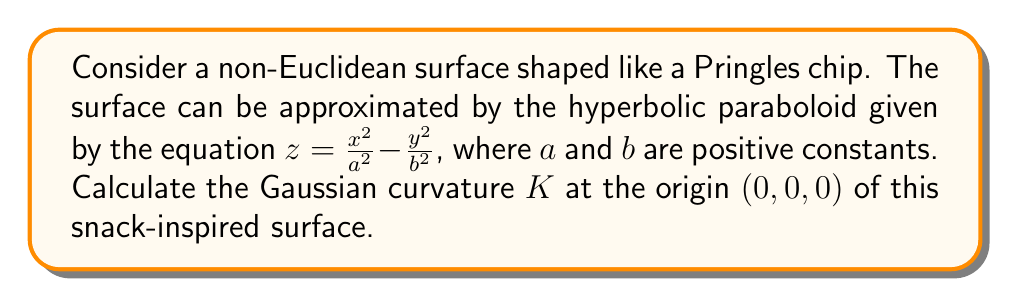Give your solution to this math problem. Let's approach this step-by-step:

1) The Gaussian curvature $K$ of a surface $z = f(x,y)$ at a point $(x,y)$ is given by:

   $$K = \frac{f_{xx}f_{yy} - f_{xy}^2}{(1 + f_x^2 + f_y^2)^2}$$

   where $f_x$, $f_y$, $f_{xx}$, $f_{yy}$, and $f_{xy}$ are partial derivatives.

2) For our surface $z = \frac{x^2}{a^2} - \frac{y^2}{b^2}$, let's calculate these derivatives:

   $f_x = \frac{2x}{a^2}$
   $f_y = -\frac{2y}{b^2}$
   $f_{xx} = \frac{2}{a^2}$
   $f_{yy} = -\frac{2}{b^2}$
   $f_{xy} = 0$

3) At the origin $(0,0,0)$, $x=0$ and $y=0$, so:

   $f_x(0,0) = 0$
   $f_y(0,0) = 0$
   $f_{xx}(0,0) = \frac{2}{a^2}$
   $f_{yy}(0,0) = -\frac{2}{b^2}$
   $f_{xy}(0,0) = 0$

4) Substituting these values into the Gaussian curvature formula:

   $$K = \frac{(\frac{2}{a^2})(-\frac{2}{b^2}) - 0^2}{(1 + 0^2 + 0^2)^2} = \frac{-\frac{4}{a^2b^2}}{1} = -\frac{4}{a^2b^2}$$

5) Therefore, the Gaussian curvature at the origin of our Pringles-shaped surface is $-\frac{4}{a^2b^2}$.
Answer: $K = -\frac{4}{a^2b^2}$ 